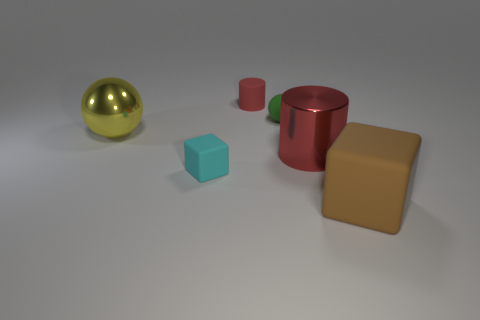Which objects have the same color as the cube in the middle? The cube in the middle of the image is a unique light blue color. None of the other objects share this color. 